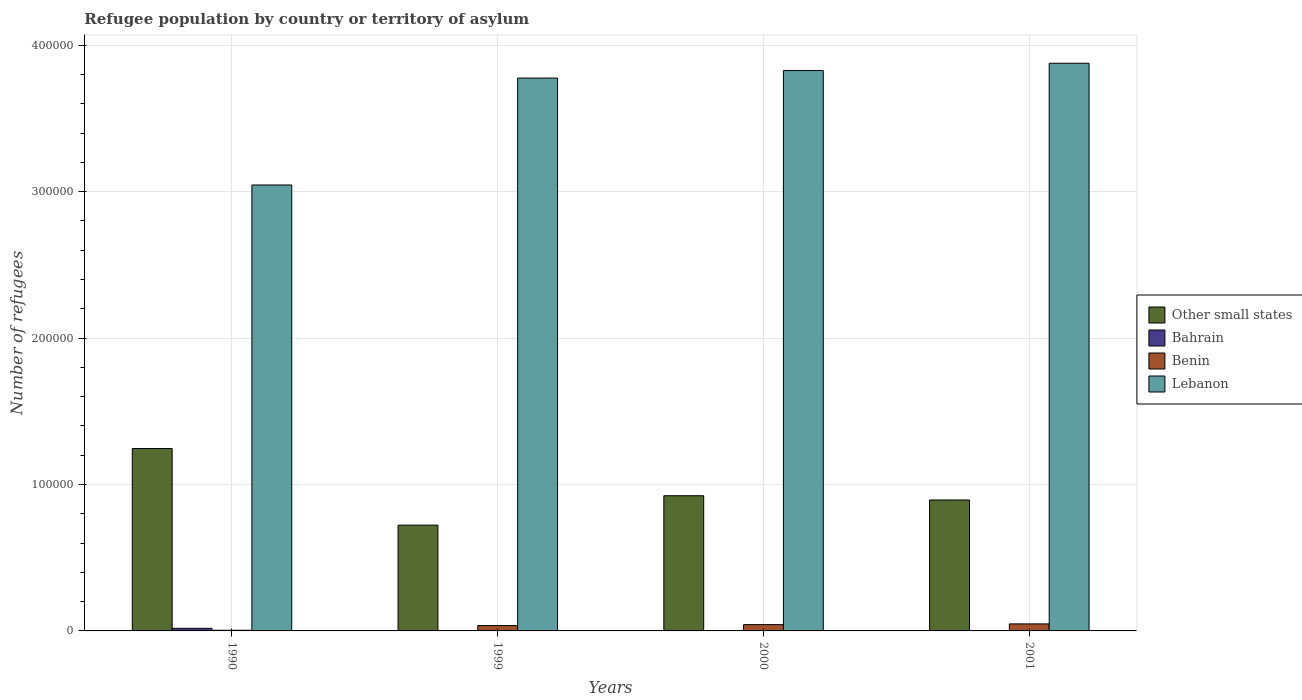How many different coloured bars are there?
Keep it short and to the point. 4. Are the number of bars per tick equal to the number of legend labels?
Offer a very short reply. Yes. Are the number of bars on each tick of the X-axis equal?
Give a very brief answer. Yes. What is the label of the 2nd group of bars from the left?
Provide a succinct answer. 1999. In how many cases, is the number of bars for a given year not equal to the number of legend labels?
Ensure brevity in your answer.  0. What is the number of refugees in Bahrain in 2000?
Your answer should be compact. 1. Across all years, what is the maximum number of refugees in Bahrain?
Keep it short and to the point. 1780. Across all years, what is the minimum number of refugees in Lebanon?
Offer a very short reply. 3.05e+05. In which year was the number of refugees in Lebanon maximum?
Give a very brief answer. 2001. What is the total number of refugees in Lebanon in the graph?
Keep it short and to the point. 1.45e+06. What is the difference between the number of refugees in Benin in 1990 and that in 2001?
Your answer should be very brief. -4343. What is the difference between the number of refugees in Benin in 2000 and the number of refugees in Other small states in 1999?
Give a very brief answer. -6.80e+04. What is the average number of refugees in Bahrain per year?
Offer a terse response. 445.75. In the year 1990, what is the difference between the number of refugees in Lebanon and number of refugees in Bahrain?
Make the answer very short. 3.03e+05. What is the ratio of the number of refugees in Other small states in 1990 to that in 1999?
Provide a succinct answer. 1.72. Is the number of refugees in Bahrain in 1999 less than that in 2001?
Offer a very short reply. No. What is the difference between the highest and the second highest number of refugees in Lebanon?
Ensure brevity in your answer.  4989. What is the difference between the highest and the lowest number of refugees in Lebanon?
Give a very brief answer. 8.31e+04. Is the sum of the number of refugees in Lebanon in 1999 and 2000 greater than the maximum number of refugees in Benin across all years?
Offer a very short reply. Yes. Is it the case that in every year, the sum of the number of refugees in Benin and number of refugees in Other small states is greater than the sum of number of refugees in Bahrain and number of refugees in Lebanon?
Your answer should be very brief. Yes. What does the 4th bar from the left in 2000 represents?
Your response must be concise. Lebanon. What does the 2nd bar from the right in 2001 represents?
Keep it short and to the point. Benin. Is it the case that in every year, the sum of the number of refugees in Other small states and number of refugees in Lebanon is greater than the number of refugees in Bahrain?
Give a very brief answer. Yes. How many bars are there?
Provide a succinct answer. 16. Does the graph contain any zero values?
Your answer should be compact. No. Does the graph contain grids?
Ensure brevity in your answer.  Yes. Where does the legend appear in the graph?
Offer a terse response. Center right. How many legend labels are there?
Offer a very short reply. 4. What is the title of the graph?
Give a very brief answer. Refugee population by country or territory of asylum. Does "Congo (Democratic)" appear as one of the legend labels in the graph?
Make the answer very short. No. What is the label or title of the X-axis?
Your answer should be very brief. Years. What is the label or title of the Y-axis?
Ensure brevity in your answer.  Number of refugees. What is the Number of refugees in Other small states in 1990?
Make the answer very short. 1.25e+05. What is the Number of refugees of Bahrain in 1990?
Give a very brief answer. 1780. What is the Number of refugees in Benin in 1990?
Your response must be concise. 456. What is the Number of refugees of Lebanon in 1990?
Offer a terse response. 3.05e+05. What is the Number of refugees in Other small states in 1999?
Offer a terse response. 7.23e+04. What is the Number of refugees of Benin in 1999?
Your answer should be compact. 3657. What is the Number of refugees of Lebanon in 1999?
Your response must be concise. 3.78e+05. What is the Number of refugees of Other small states in 2000?
Keep it short and to the point. 9.23e+04. What is the Number of refugees of Benin in 2000?
Ensure brevity in your answer.  4296. What is the Number of refugees in Lebanon in 2000?
Your answer should be very brief. 3.83e+05. What is the Number of refugees in Other small states in 2001?
Your answer should be very brief. 8.94e+04. What is the Number of refugees in Benin in 2001?
Provide a short and direct response. 4799. What is the Number of refugees in Lebanon in 2001?
Your answer should be compact. 3.88e+05. Across all years, what is the maximum Number of refugees of Other small states?
Keep it short and to the point. 1.25e+05. Across all years, what is the maximum Number of refugees in Bahrain?
Offer a very short reply. 1780. Across all years, what is the maximum Number of refugees of Benin?
Provide a succinct answer. 4799. Across all years, what is the maximum Number of refugees of Lebanon?
Provide a succinct answer. 3.88e+05. Across all years, what is the minimum Number of refugees of Other small states?
Ensure brevity in your answer.  7.23e+04. Across all years, what is the minimum Number of refugees of Benin?
Keep it short and to the point. 456. Across all years, what is the minimum Number of refugees in Lebanon?
Offer a very short reply. 3.05e+05. What is the total Number of refugees of Other small states in the graph?
Your response must be concise. 3.79e+05. What is the total Number of refugees of Bahrain in the graph?
Provide a short and direct response. 1783. What is the total Number of refugees of Benin in the graph?
Your response must be concise. 1.32e+04. What is the total Number of refugees in Lebanon in the graph?
Your response must be concise. 1.45e+06. What is the difference between the Number of refugees in Other small states in 1990 and that in 1999?
Your answer should be compact. 5.23e+04. What is the difference between the Number of refugees in Bahrain in 1990 and that in 1999?
Provide a short and direct response. 1779. What is the difference between the Number of refugees in Benin in 1990 and that in 1999?
Your response must be concise. -3201. What is the difference between the Number of refugees of Lebanon in 1990 and that in 1999?
Provide a short and direct response. -7.30e+04. What is the difference between the Number of refugees in Other small states in 1990 and that in 2000?
Provide a succinct answer. 3.22e+04. What is the difference between the Number of refugees of Bahrain in 1990 and that in 2000?
Your answer should be compact. 1779. What is the difference between the Number of refugees in Benin in 1990 and that in 2000?
Offer a terse response. -3840. What is the difference between the Number of refugees of Lebanon in 1990 and that in 2000?
Keep it short and to the point. -7.81e+04. What is the difference between the Number of refugees of Other small states in 1990 and that in 2001?
Provide a short and direct response. 3.51e+04. What is the difference between the Number of refugees of Bahrain in 1990 and that in 2001?
Your response must be concise. 1779. What is the difference between the Number of refugees of Benin in 1990 and that in 2001?
Your response must be concise. -4343. What is the difference between the Number of refugees of Lebanon in 1990 and that in 2001?
Keep it short and to the point. -8.31e+04. What is the difference between the Number of refugees in Other small states in 1999 and that in 2000?
Your response must be concise. -2.01e+04. What is the difference between the Number of refugees in Bahrain in 1999 and that in 2000?
Ensure brevity in your answer.  0. What is the difference between the Number of refugees of Benin in 1999 and that in 2000?
Provide a succinct answer. -639. What is the difference between the Number of refugees in Lebanon in 1999 and that in 2000?
Keep it short and to the point. -5132. What is the difference between the Number of refugees in Other small states in 1999 and that in 2001?
Ensure brevity in your answer.  -1.72e+04. What is the difference between the Number of refugees in Bahrain in 1999 and that in 2001?
Your answer should be compact. 0. What is the difference between the Number of refugees of Benin in 1999 and that in 2001?
Provide a succinct answer. -1142. What is the difference between the Number of refugees in Lebanon in 1999 and that in 2001?
Your answer should be very brief. -1.01e+04. What is the difference between the Number of refugees in Other small states in 2000 and that in 2001?
Your answer should be compact. 2899. What is the difference between the Number of refugees in Bahrain in 2000 and that in 2001?
Your answer should be very brief. 0. What is the difference between the Number of refugees of Benin in 2000 and that in 2001?
Ensure brevity in your answer.  -503. What is the difference between the Number of refugees of Lebanon in 2000 and that in 2001?
Make the answer very short. -4989. What is the difference between the Number of refugees of Other small states in 1990 and the Number of refugees of Bahrain in 1999?
Keep it short and to the point. 1.25e+05. What is the difference between the Number of refugees in Other small states in 1990 and the Number of refugees in Benin in 1999?
Your response must be concise. 1.21e+05. What is the difference between the Number of refugees of Other small states in 1990 and the Number of refugees of Lebanon in 1999?
Offer a terse response. -2.53e+05. What is the difference between the Number of refugees in Bahrain in 1990 and the Number of refugees in Benin in 1999?
Offer a terse response. -1877. What is the difference between the Number of refugees of Bahrain in 1990 and the Number of refugees of Lebanon in 1999?
Your answer should be compact. -3.76e+05. What is the difference between the Number of refugees in Benin in 1990 and the Number of refugees in Lebanon in 1999?
Give a very brief answer. -3.77e+05. What is the difference between the Number of refugees of Other small states in 1990 and the Number of refugees of Bahrain in 2000?
Your answer should be very brief. 1.25e+05. What is the difference between the Number of refugees in Other small states in 1990 and the Number of refugees in Benin in 2000?
Your answer should be very brief. 1.20e+05. What is the difference between the Number of refugees of Other small states in 1990 and the Number of refugees of Lebanon in 2000?
Keep it short and to the point. -2.58e+05. What is the difference between the Number of refugees of Bahrain in 1990 and the Number of refugees of Benin in 2000?
Your answer should be very brief. -2516. What is the difference between the Number of refugees in Bahrain in 1990 and the Number of refugees in Lebanon in 2000?
Your answer should be compact. -3.81e+05. What is the difference between the Number of refugees in Benin in 1990 and the Number of refugees in Lebanon in 2000?
Your response must be concise. -3.82e+05. What is the difference between the Number of refugees of Other small states in 1990 and the Number of refugees of Bahrain in 2001?
Provide a succinct answer. 1.25e+05. What is the difference between the Number of refugees of Other small states in 1990 and the Number of refugees of Benin in 2001?
Offer a terse response. 1.20e+05. What is the difference between the Number of refugees of Other small states in 1990 and the Number of refugees of Lebanon in 2001?
Provide a short and direct response. -2.63e+05. What is the difference between the Number of refugees of Bahrain in 1990 and the Number of refugees of Benin in 2001?
Make the answer very short. -3019. What is the difference between the Number of refugees in Bahrain in 1990 and the Number of refugees in Lebanon in 2001?
Give a very brief answer. -3.86e+05. What is the difference between the Number of refugees of Benin in 1990 and the Number of refugees of Lebanon in 2001?
Keep it short and to the point. -3.87e+05. What is the difference between the Number of refugees of Other small states in 1999 and the Number of refugees of Bahrain in 2000?
Keep it short and to the point. 7.23e+04. What is the difference between the Number of refugees of Other small states in 1999 and the Number of refugees of Benin in 2000?
Provide a succinct answer. 6.80e+04. What is the difference between the Number of refugees of Other small states in 1999 and the Number of refugees of Lebanon in 2000?
Make the answer very short. -3.10e+05. What is the difference between the Number of refugees of Bahrain in 1999 and the Number of refugees of Benin in 2000?
Keep it short and to the point. -4295. What is the difference between the Number of refugees in Bahrain in 1999 and the Number of refugees in Lebanon in 2000?
Keep it short and to the point. -3.83e+05. What is the difference between the Number of refugees in Benin in 1999 and the Number of refugees in Lebanon in 2000?
Give a very brief answer. -3.79e+05. What is the difference between the Number of refugees of Other small states in 1999 and the Number of refugees of Bahrain in 2001?
Offer a very short reply. 7.23e+04. What is the difference between the Number of refugees of Other small states in 1999 and the Number of refugees of Benin in 2001?
Provide a short and direct response. 6.75e+04. What is the difference between the Number of refugees in Other small states in 1999 and the Number of refugees in Lebanon in 2001?
Offer a terse response. -3.15e+05. What is the difference between the Number of refugees of Bahrain in 1999 and the Number of refugees of Benin in 2001?
Give a very brief answer. -4798. What is the difference between the Number of refugees in Bahrain in 1999 and the Number of refugees in Lebanon in 2001?
Your response must be concise. -3.88e+05. What is the difference between the Number of refugees in Benin in 1999 and the Number of refugees in Lebanon in 2001?
Your response must be concise. -3.84e+05. What is the difference between the Number of refugees of Other small states in 2000 and the Number of refugees of Bahrain in 2001?
Offer a very short reply. 9.23e+04. What is the difference between the Number of refugees of Other small states in 2000 and the Number of refugees of Benin in 2001?
Give a very brief answer. 8.75e+04. What is the difference between the Number of refugees in Other small states in 2000 and the Number of refugees in Lebanon in 2001?
Your response must be concise. -2.95e+05. What is the difference between the Number of refugees of Bahrain in 2000 and the Number of refugees of Benin in 2001?
Offer a terse response. -4798. What is the difference between the Number of refugees of Bahrain in 2000 and the Number of refugees of Lebanon in 2001?
Your answer should be compact. -3.88e+05. What is the difference between the Number of refugees of Benin in 2000 and the Number of refugees of Lebanon in 2001?
Your response must be concise. -3.83e+05. What is the average Number of refugees in Other small states per year?
Provide a short and direct response. 9.47e+04. What is the average Number of refugees of Bahrain per year?
Make the answer very short. 445.75. What is the average Number of refugees in Benin per year?
Provide a short and direct response. 3302. What is the average Number of refugees of Lebanon per year?
Give a very brief answer. 3.63e+05. In the year 1990, what is the difference between the Number of refugees in Other small states and Number of refugees in Bahrain?
Your response must be concise. 1.23e+05. In the year 1990, what is the difference between the Number of refugees in Other small states and Number of refugees in Benin?
Provide a succinct answer. 1.24e+05. In the year 1990, what is the difference between the Number of refugees of Other small states and Number of refugees of Lebanon?
Provide a succinct answer. -1.80e+05. In the year 1990, what is the difference between the Number of refugees in Bahrain and Number of refugees in Benin?
Offer a terse response. 1324. In the year 1990, what is the difference between the Number of refugees in Bahrain and Number of refugees in Lebanon?
Your answer should be compact. -3.03e+05. In the year 1990, what is the difference between the Number of refugees in Benin and Number of refugees in Lebanon?
Provide a short and direct response. -3.04e+05. In the year 1999, what is the difference between the Number of refugees of Other small states and Number of refugees of Bahrain?
Your answer should be very brief. 7.23e+04. In the year 1999, what is the difference between the Number of refugees of Other small states and Number of refugees of Benin?
Your answer should be compact. 6.86e+04. In the year 1999, what is the difference between the Number of refugees in Other small states and Number of refugees in Lebanon?
Give a very brief answer. -3.05e+05. In the year 1999, what is the difference between the Number of refugees in Bahrain and Number of refugees in Benin?
Your answer should be very brief. -3656. In the year 1999, what is the difference between the Number of refugees in Bahrain and Number of refugees in Lebanon?
Give a very brief answer. -3.78e+05. In the year 1999, what is the difference between the Number of refugees of Benin and Number of refugees of Lebanon?
Your answer should be compact. -3.74e+05. In the year 2000, what is the difference between the Number of refugees in Other small states and Number of refugees in Bahrain?
Offer a terse response. 9.23e+04. In the year 2000, what is the difference between the Number of refugees in Other small states and Number of refugees in Benin?
Provide a short and direct response. 8.80e+04. In the year 2000, what is the difference between the Number of refugees in Other small states and Number of refugees in Lebanon?
Offer a very short reply. -2.90e+05. In the year 2000, what is the difference between the Number of refugees in Bahrain and Number of refugees in Benin?
Keep it short and to the point. -4295. In the year 2000, what is the difference between the Number of refugees in Bahrain and Number of refugees in Lebanon?
Give a very brief answer. -3.83e+05. In the year 2000, what is the difference between the Number of refugees of Benin and Number of refugees of Lebanon?
Provide a succinct answer. -3.78e+05. In the year 2001, what is the difference between the Number of refugees of Other small states and Number of refugees of Bahrain?
Your answer should be compact. 8.94e+04. In the year 2001, what is the difference between the Number of refugees in Other small states and Number of refugees in Benin?
Provide a succinct answer. 8.46e+04. In the year 2001, what is the difference between the Number of refugees in Other small states and Number of refugees in Lebanon?
Provide a succinct answer. -2.98e+05. In the year 2001, what is the difference between the Number of refugees in Bahrain and Number of refugees in Benin?
Your answer should be very brief. -4798. In the year 2001, what is the difference between the Number of refugees of Bahrain and Number of refugees of Lebanon?
Provide a short and direct response. -3.88e+05. In the year 2001, what is the difference between the Number of refugees in Benin and Number of refugees in Lebanon?
Make the answer very short. -3.83e+05. What is the ratio of the Number of refugees in Other small states in 1990 to that in 1999?
Make the answer very short. 1.72. What is the ratio of the Number of refugees of Bahrain in 1990 to that in 1999?
Ensure brevity in your answer.  1780. What is the ratio of the Number of refugees in Benin in 1990 to that in 1999?
Your response must be concise. 0.12. What is the ratio of the Number of refugees of Lebanon in 1990 to that in 1999?
Keep it short and to the point. 0.81. What is the ratio of the Number of refugees of Other small states in 1990 to that in 2000?
Make the answer very short. 1.35. What is the ratio of the Number of refugees in Bahrain in 1990 to that in 2000?
Provide a short and direct response. 1780. What is the ratio of the Number of refugees of Benin in 1990 to that in 2000?
Keep it short and to the point. 0.11. What is the ratio of the Number of refugees of Lebanon in 1990 to that in 2000?
Offer a very short reply. 0.8. What is the ratio of the Number of refugees of Other small states in 1990 to that in 2001?
Your answer should be very brief. 1.39. What is the ratio of the Number of refugees of Bahrain in 1990 to that in 2001?
Offer a terse response. 1780. What is the ratio of the Number of refugees in Benin in 1990 to that in 2001?
Keep it short and to the point. 0.1. What is the ratio of the Number of refugees in Lebanon in 1990 to that in 2001?
Give a very brief answer. 0.79. What is the ratio of the Number of refugees in Other small states in 1999 to that in 2000?
Provide a short and direct response. 0.78. What is the ratio of the Number of refugees of Benin in 1999 to that in 2000?
Your response must be concise. 0.85. What is the ratio of the Number of refugees of Lebanon in 1999 to that in 2000?
Your answer should be compact. 0.99. What is the ratio of the Number of refugees in Other small states in 1999 to that in 2001?
Make the answer very short. 0.81. What is the ratio of the Number of refugees of Benin in 1999 to that in 2001?
Make the answer very short. 0.76. What is the ratio of the Number of refugees of Lebanon in 1999 to that in 2001?
Your response must be concise. 0.97. What is the ratio of the Number of refugees in Other small states in 2000 to that in 2001?
Offer a terse response. 1.03. What is the ratio of the Number of refugees of Bahrain in 2000 to that in 2001?
Offer a very short reply. 1. What is the ratio of the Number of refugees in Benin in 2000 to that in 2001?
Your answer should be compact. 0.9. What is the ratio of the Number of refugees of Lebanon in 2000 to that in 2001?
Your answer should be compact. 0.99. What is the difference between the highest and the second highest Number of refugees of Other small states?
Your response must be concise. 3.22e+04. What is the difference between the highest and the second highest Number of refugees in Bahrain?
Provide a succinct answer. 1779. What is the difference between the highest and the second highest Number of refugees of Benin?
Your answer should be very brief. 503. What is the difference between the highest and the second highest Number of refugees in Lebanon?
Provide a succinct answer. 4989. What is the difference between the highest and the lowest Number of refugees in Other small states?
Provide a succinct answer. 5.23e+04. What is the difference between the highest and the lowest Number of refugees of Bahrain?
Keep it short and to the point. 1779. What is the difference between the highest and the lowest Number of refugees in Benin?
Give a very brief answer. 4343. What is the difference between the highest and the lowest Number of refugees of Lebanon?
Your answer should be compact. 8.31e+04. 